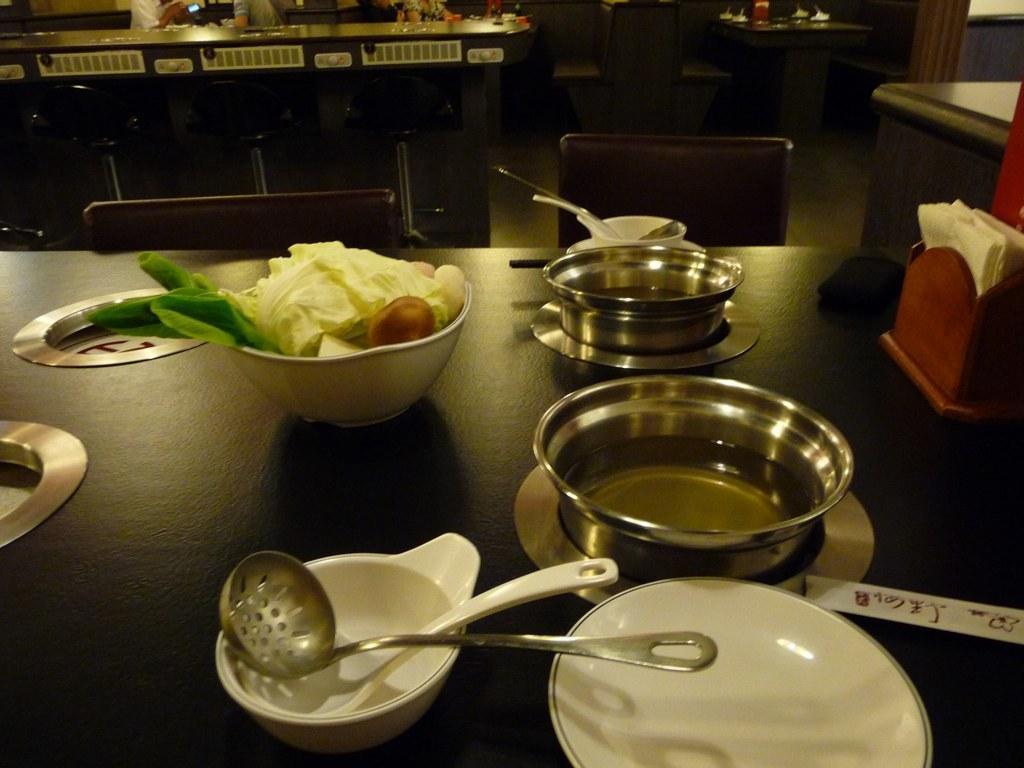Describe this image in one or two sentences. In the image we can see a table, on the table, we can see the bowl and vegetable in the bowl, plate, metal container, curry spoons, tissue paper and a wooden box. Here we can see chairs, there are even people wearing clothes and the floor. 